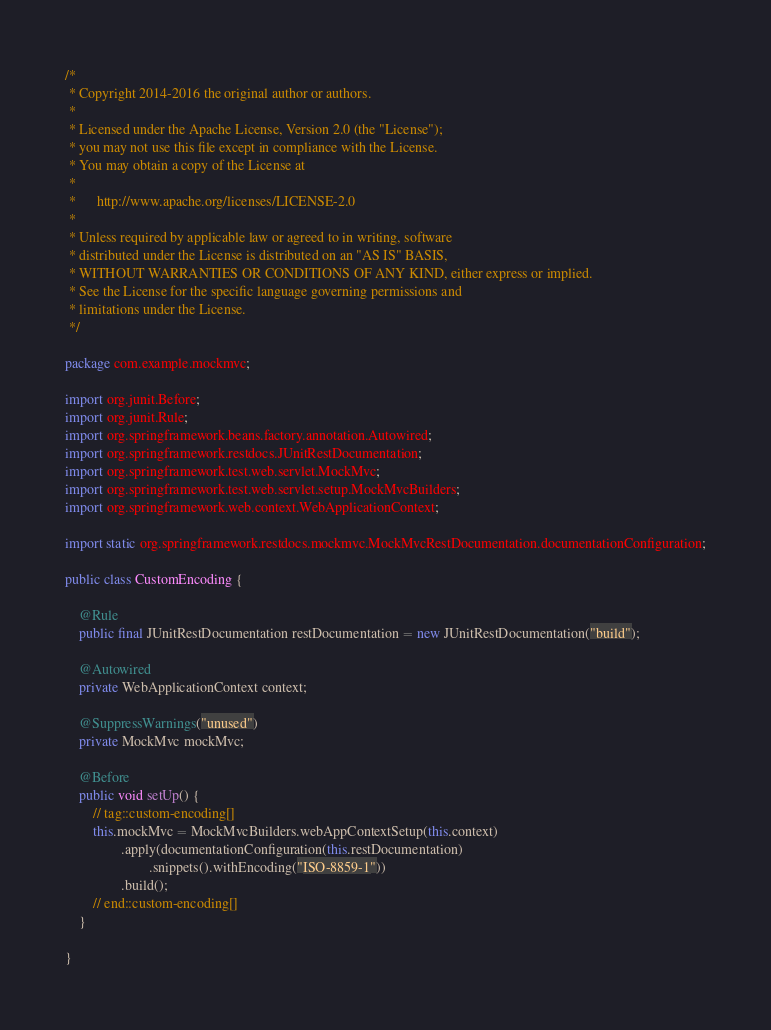Convert code to text. <code><loc_0><loc_0><loc_500><loc_500><_Java_>/*
 * Copyright 2014-2016 the original author or authors.
 *
 * Licensed under the Apache License, Version 2.0 (the "License");
 * you may not use this file except in compliance with the License.
 * You may obtain a copy of the License at
 *
 *      http://www.apache.org/licenses/LICENSE-2.0
 *
 * Unless required by applicable law or agreed to in writing, software
 * distributed under the License is distributed on an "AS IS" BASIS,
 * WITHOUT WARRANTIES OR CONDITIONS OF ANY KIND, either express or implied.
 * See the License for the specific language governing permissions and
 * limitations under the License.
 */

package com.example.mockmvc;

import org.junit.Before;
import org.junit.Rule;
import org.springframework.beans.factory.annotation.Autowired;
import org.springframework.restdocs.JUnitRestDocumentation;
import org.springframework.test.web.servlet.MockMvc;
import org.springframework.test.web.servlet.setup.MockMvcBuilders;
import org.springframework.web.context.WebApplicationContext;

import static org.springframework.restdocs.mockmvc.MockMvcRestDocumentation.documentationConfiguration;

public class CustomEncoding {

	@Rule
	public final JUnitRestDocumentation restDocumentation = new JUnitRestDocumentation("build");

	@Autowired
	private WebApplicationContext context;

	@SuppressWarnings("unused")
	private MockMvc mockMvc;

	@Before
	public void setUp() {
		// tag::custom-encoding[]
		this.mockMvc = MockMvcBuilders.webAppContextSetup(this.context)
				.apply(documentationConfiguration(this.restDocumentation)
						.snippets().withEncoding("ISO-8859-1"))
				.build();
		// end::custom-encoding[]
	}

}
</code> 